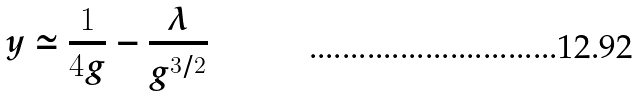Convert formula to latex. <formula><loc_0><loc_0><loc_500><loc_500>y \simeq \frac { 1 } { 4 g } - \frac { \lambda } { g ^ { 3 / 2 } }</formula> 